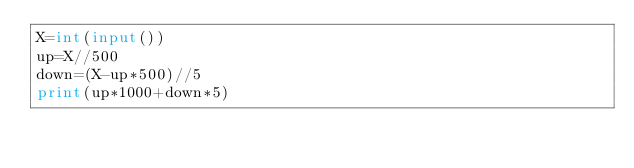Convert code to text. <code><loc_0><loc_0><loc_500><loc_500><_Python_>X=int(input())
up=X//500
down=(X-up*500)//5
print(up*1000+down*5)</code> 